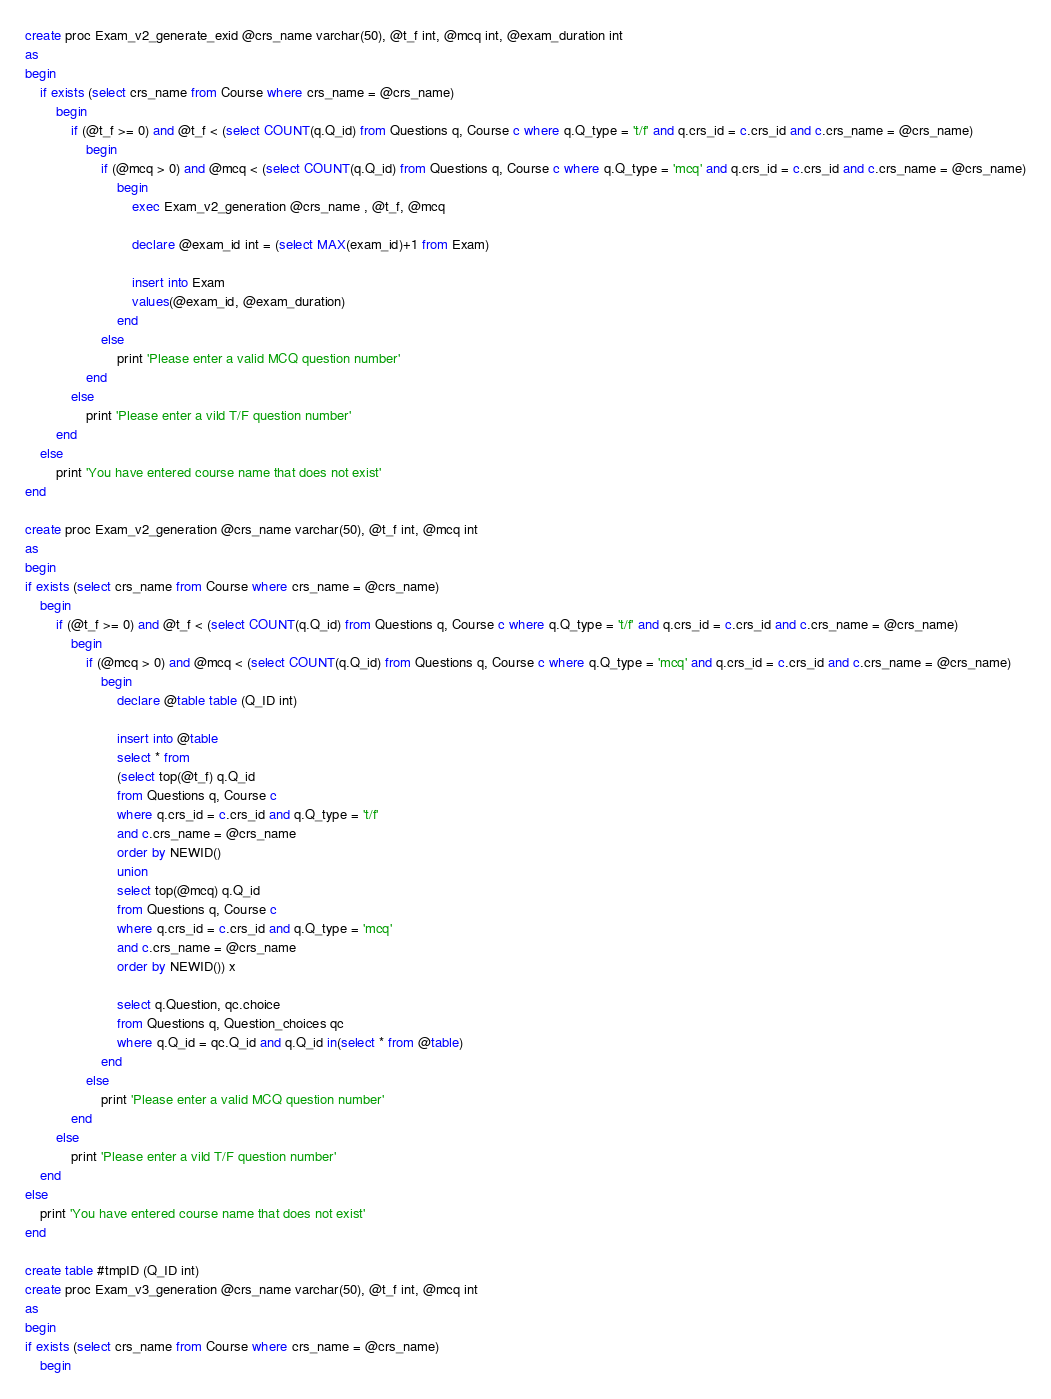<code> <loc_0><loc_0><loc_500><loc_500><_SQL_>create proc Exam_v2_generate_exid @crs_name varchar(50), @t_f int, @mcq int, @exam_duration int
as
begin
	if exists (select crs_name from Course where crs_name = @crs_name)
		begin
			if (@t_f >= 0) and @t_f < (select COUNT(q.Q_id) from Questions q, Course c where q.Q_type = 't/f' and q.crs_id = c.crs_id and c.crs_name = @crs_name)
				begin
					if (@mcq > 0) and @mcq < (select COUNT(q.Q_id) from Questions q, Course c where q.Q_type = 'mcq' and q.crs_id = c.crs_id and c.crs_name = @crs_name)
						begin
							exec Exam_v2_generation @crs_name , @t_f, @mcq
	
							declare @exam_id int = (select MAX(exam_id)+1 from Exam)

							insert into Exam
							values(@exam_id, @exam_duration)
						end
					else
						print 'Please enter a valid MCQ question number'
				end
			else
				print 'Please enter a vild T/F question number'
		end
	else
		print 'You have entered course name that does not exist'
end

create proc Exam_v2_generation @crs_name varchar(50), @t_f int, @mcq int
as
begin
if exists (select crs_name from Course where crs_name = @crs_name)
	begin
		if (@t_f >= 0) and @t_f < (select COUNT(q.Q_id) from Questions q, Course c where q.Q_type = 't/f' and q.crs_id = c.crs_id and c.crs_name = @crs_name)
			begin
				if (@mcq > 0) and @mcq < (select COUNT(q.Q_id) from Questions q, Course c where q.Q_type = 'mcq' and q.crs_id = c.crs_id and c.crs_name = @crs_name)
					begin
						declare @table table (Q_ID int)
	
						insert into @table
						select * from
						(select top(@t_f) q.Q_id
						from Questions q, Course c
						where q.crs_id = c.crs_id and q.Q_type = 't/f'
						and c.crs_name = @crs_name
						order by NEWID()
						union
						select top(@mcq) q.Q_id
						from Questions q, Course c
						where q.crs_id = c.crs_id and q.Q_type = 'mcq'
						and c.crs_name = @crs_name
						order by NEWID()) x
	
						select q.Question, qc.choice
						from Questions q, Question_choices qc
						where q.Q_id = qc.Q_id and q.Q_id in(select * from @table)
					end
				else
					print 'Please enter a valid MCQ question number'
			end
		else
			print 'Please enter a vild T/F question number'
	end
else
	print 'You have entered course name that does not exist'
end

create table #tmpID (Q_ID int)
create proc Exam_v3_generation @crs_name varchar(50), @t_f int, @mcq int
as
begin
if exists (select crs_name from Course where crs_name = @crs_name)
	begin</code> 